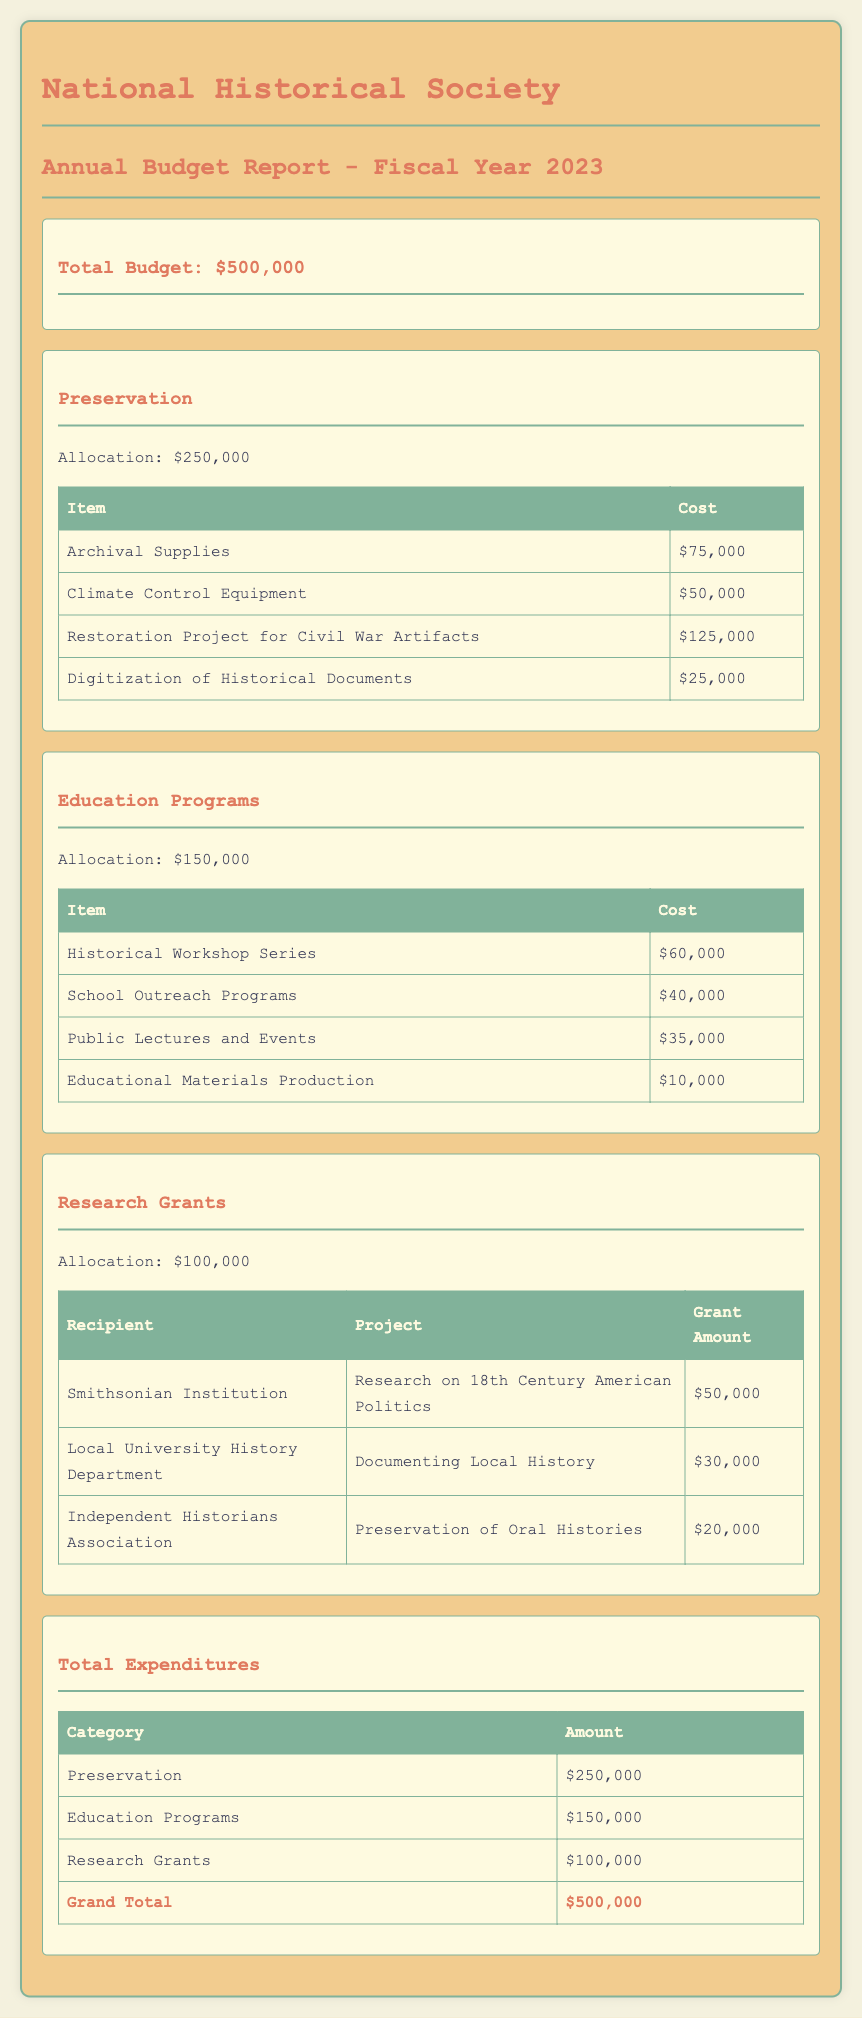What is the total budget for the National Historical Society in 2023? The total budget is stated as $500,000 in the document.
Answer: $500,000 How much is allocated for preservation? The budget section specifies that the allocation for preservation is $250,000.
Answer: $250,000 What is the cost of archival supplies? The document lists archival supplies with a cost of $75,000 under the preservation section.
Answer: $75,000 Which organization received a grant for research on 18th Century American Politics? The recipient for this project is the Smithsonian Institution, mentioned in the research grants section.
Answer: Smithsonian Institution What is the total allocation for education programs? The education programs section states an allocation of $150,000 for that category.
Answer: $150,000 How much did the Independent Historians Association receive for the preservation of Oral Histories? The document states that they received $20,000 for this project, which can be found under research grants.
Answer: $20,000 What is the cost for the school outreach programs? The school outreach programs are listed as costing $40,000 in the education programs section.
Answer: $40,000 What is the grand total for all expenditures? The grand total is provided as $500,000 in the total expenditures section of the report.
Answer: $500,000 